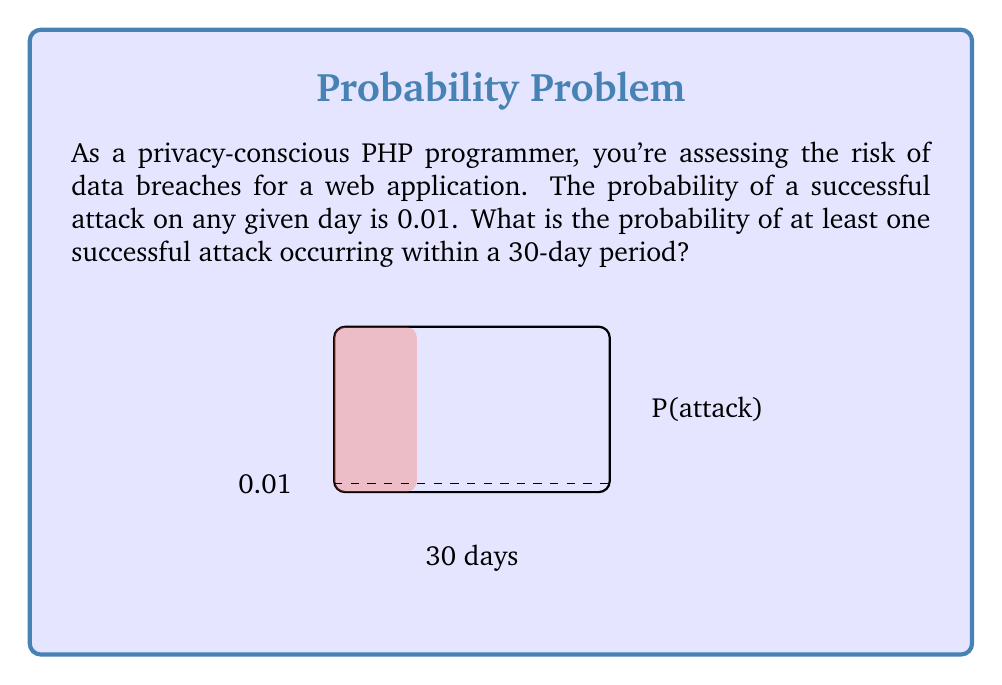Give your solution to this math problem. Let's approach this step-by-step using probability theory:

1) First, let's consider the probability of no successful attack occurring on a single day:
   $P(\text{no attack}) = 1 - P(\text{attack}) = 1 - 0.01 = 0.99$

2) For no attacks to occur in 30 days, we need this to happen 30 times in a row. The probability of independent events occurring together is the product of their individual probabilities:
   $P(\text{no attack in 30 days}) = (0.99)^{30}$

3) We can calculate this:
   $P(\text{no attack in 30 days}) = (0.99)^{30} \approx 0.7397$

4) The question asks for the probability of at least one attack. This is the complement of the probability of no attacks:
   $P(\text{at least one attack}) = 1 - P(\text{no attack in 30 days})$

5) Therefore:
   $P(\text{at least one attack}) = 1 - 0.7397 \approx 0.2603$

6) Converting to a percentage:
   $0.2603 \times 100\% \approx 26.03\%$

This means there's about a 26.03% chance of at least one successful attack within a 30-day period.
Answer: 26.03% 